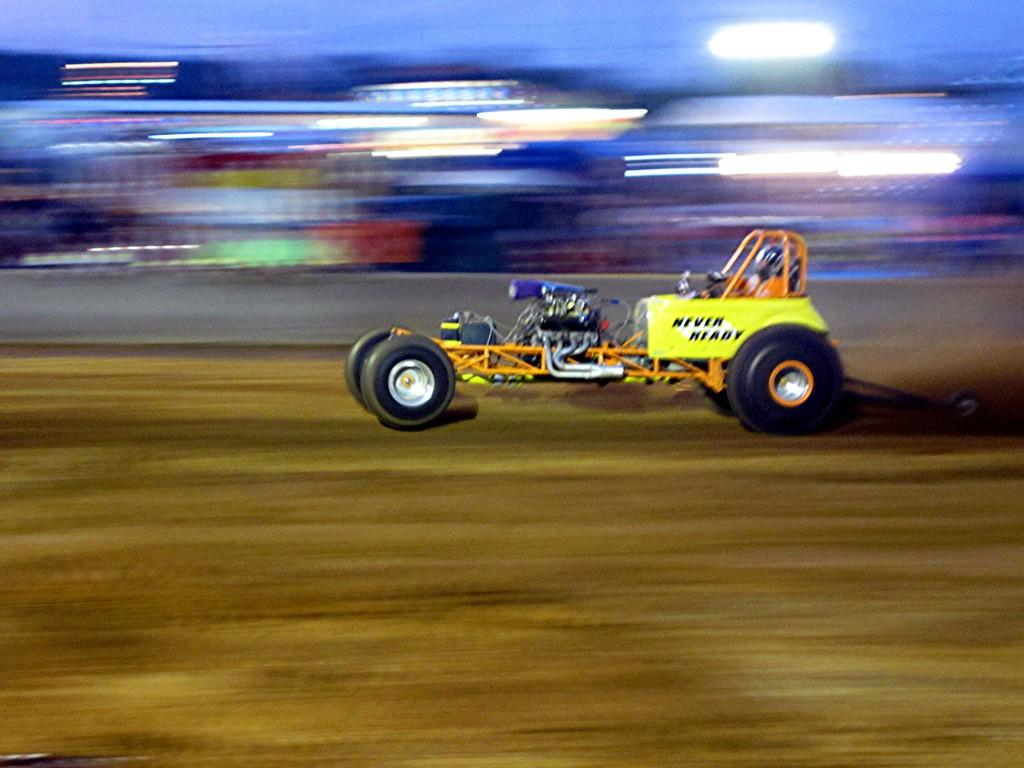What is the main subject of the image? There is a vehicle in the image. Where is the vehicle located in the image? The vehicle is in the middle of the image. What feature can be seen at the top of the vehicle? There are lights at the top of the vehicle. How many pigs are visible inside the vehicle in the image? There are no pigs visible inside the vehicle in the image. What type of steel is used to construct the vehicle? The type of steel used to construct the vehicle is not mentioned in the image. 